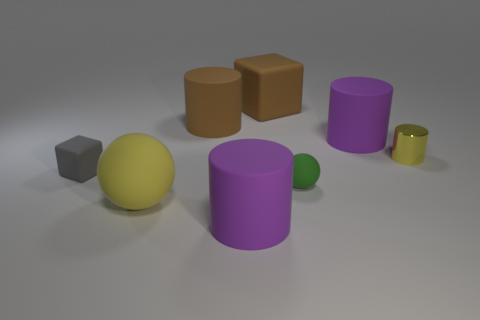There is a big sphere in front of the small green matte ball; does it have the same color as the metal object?
Give a very brief answer. Yes. What is the size of the yellow thing that is the same shape as the green matte object?
Ensure brevity in your answer.  Large. How many objects are matte cylinders in front of the small yellow cylinder or big purple things behind the tiny yellow cylinder?
Give a very brief answer. 2. There is a large brown object that is right of the large cylinder in front of the tiny metal thing; what shape is it?
Offer a very short reply. Cube. Are there any other things of the same color as the tiny block?
Provide a short and direct response. No. How many things are either small yellow cylinders or matte cubes?
Offer a very short reply. 3. Is there a yellow metal cylinder that has the same size as the gray object?
Offer a terse response. Yes. What is the shape of the small gray object?
Provide a succinct answer. Cube. Is the number of big brown rubber cubes that are in front of the yellow metal cylinder greater than the number of large rubber cubes that are in front of the large brown cube?
Give a very brief answer. No. There is a large thing in front of the large yellow sphere; is it the same color as the big rubber thing that is to the right of the green sphere?
Provide a succinct answer. Yes. 